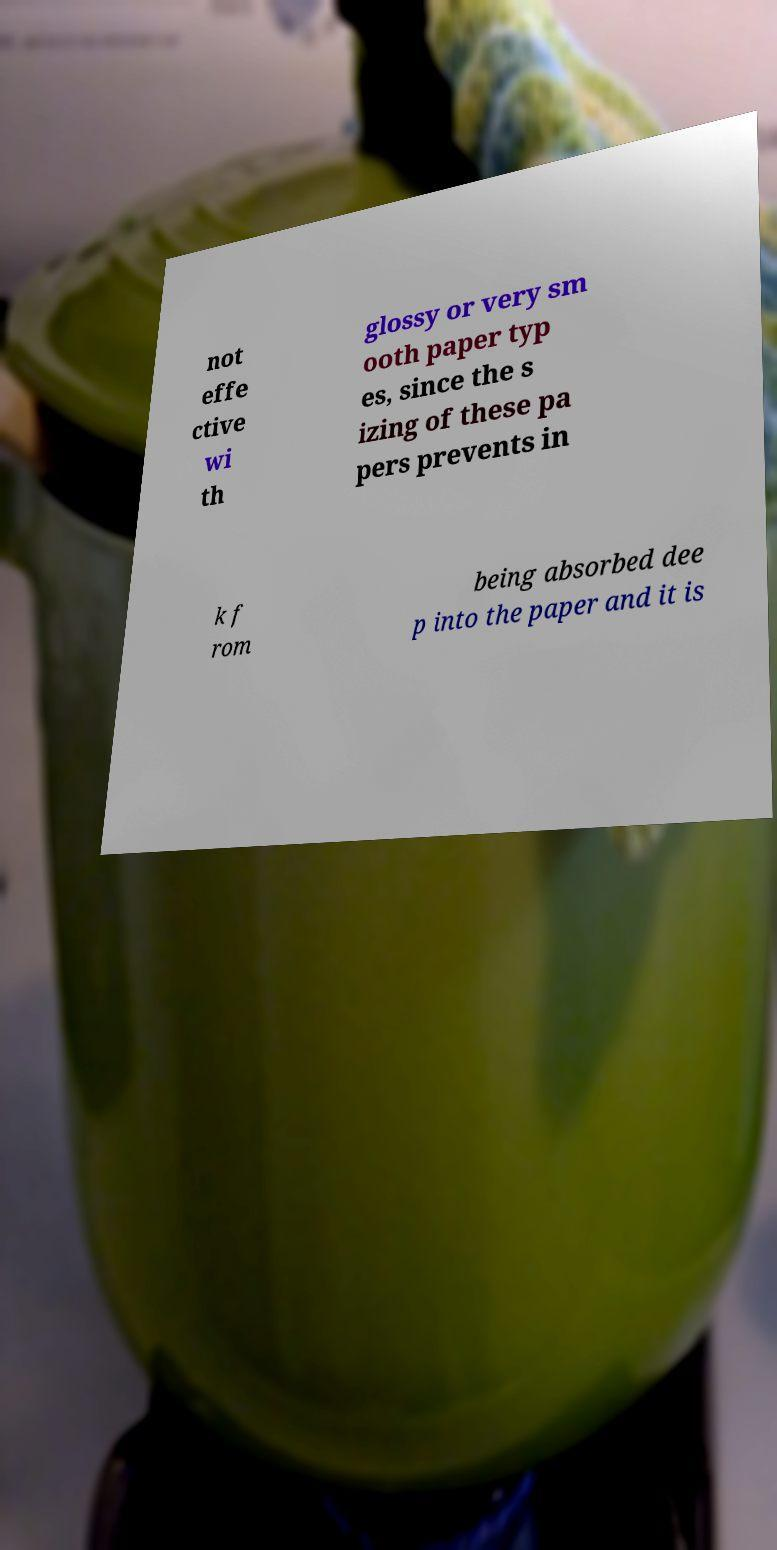For documentation purposes, I need the text within this image transcribed. Could you provide that? not effe ctive wi th glossy or very sm ooth paper typ es, since the s izing of these pa pers prevents in k f rom being absorbed dee p into the paper and it is 